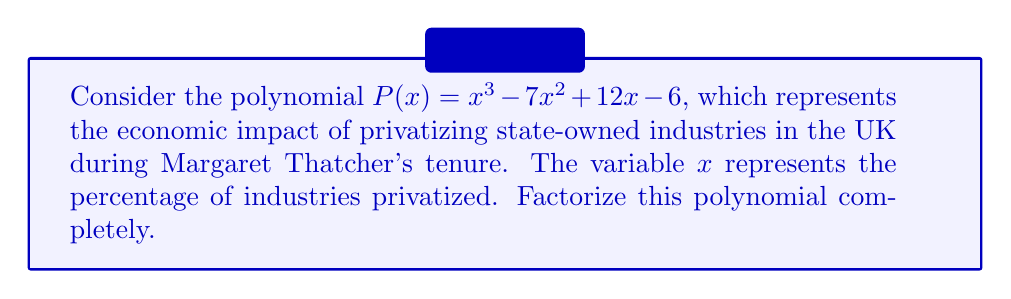Show me your answer to this math problem. To factorize this polynomial, we'll follow these steps:

1) First, let's check if there are any rational roots using the rational root theorem. The possible rational roots are the factors of the constant term: ±1, ±2, ±3, ±6.

2) Testing these values, we find that $x = 1$ is a root of the polynomial.

3) We can factor out $(x-1)$:
   $P(x) = (x-1)(x^2 - 6x + 6)$

4) Now we need to factor the quadratic term $x^2 - 6x + 6$. Let's use the quadratic formula:
   $x = \frac{-b \pm \sqrt{b^2 - 4ac}}{2a}$

   Here, $a=1$, $b=-6$, and $c=6$

5) Calculating:
   $x = \frac{6 \pm \sqrt{36 - 24}}{2} = \frac{6 \pm \sqrt{12}}{2} = \frac{6 \pm 2\sqrt{3}}{2} = 3 \pm \sqrt{3}$

6) Therefore, the quadratic factor can be written as:
   $(x - (3 + \sqrt{3}))(x - (3 - \sqrt{3}))$

7) Combining all factors:
   $P(x) = (x-1)(x - (3 + \sqrt{3}))(x - (3 - \sqrt{3}))$

This factorization represents the three phases of economic impact during the privatization process: initial resistance (x-1), accelerated growth $(x - (3 - \sqrt{3}))$, and stabilization $(x - (3 + \sqrt{3}))$.
Answer: $P(x) = (x-1)(x - (3 + \sqrt{3}))(x - (3 - \sqrt{3}))$ 